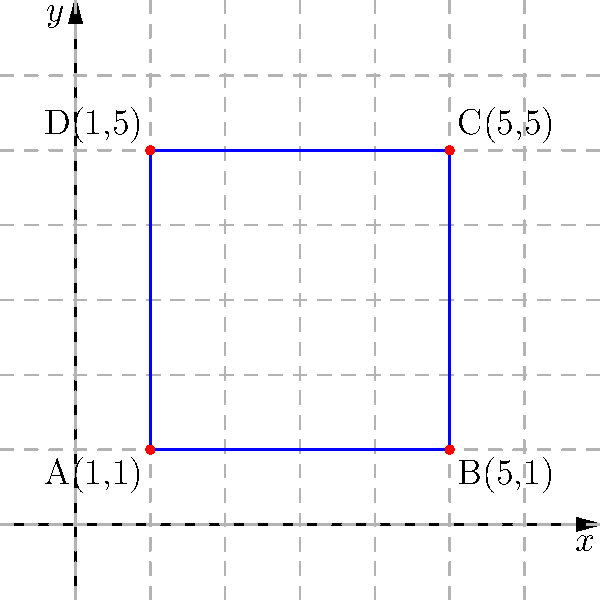As a homeschooling expert, you're teaching coordinate geometry to your students. Consider a rectangle ABCD with vertices at A(1,1), B(5,1), C(5,5), and D(1,5). Calculate the area of this rectangle and explain how you would guide a student through this problem using the coordinate plane. To guide a student through this problem, we can follow these steps:

1. Identify the coordinates of the vertices:
   A(1,1), B(5,1), C(5,5), D(1,5)

2. Explain that to find the area of a rectangle, we need its length and width.

3. To find the length:
   - Choose either the bottom or top side of the rectangle.
   - Use the distance formula: $d = \sqrt{(x_2-x_1)^2 + (y_2-y_1)^2}$
   - For side AB: $\sqrt{(5-1)^2 + (1-1)^2} = \sqrt{16 + 0} = 4$

4. To find the width:
   - Choose either the left or right side of the rectangle.
   - Use the distance formula again.
   - For side AD: $\sqrt{(1-1)^2 + (5-1)^2} = \sqrt{0 + 16} = 4$

5. Calculate the area:
   Area = length × width = 4 × 4 = 16 square units

6. Emphasize that we can also find the length and width by subtracting x-coordinates and y-coordinates:
   - Length: 5 - 1 = 4
   - Width: 5 - 1 = 4

This approach helps students understand how to use the coordinate system to find distances and areas, reinforcing their understanding of the coordinate plane and geometric concepts.
Answer: 16 square units 